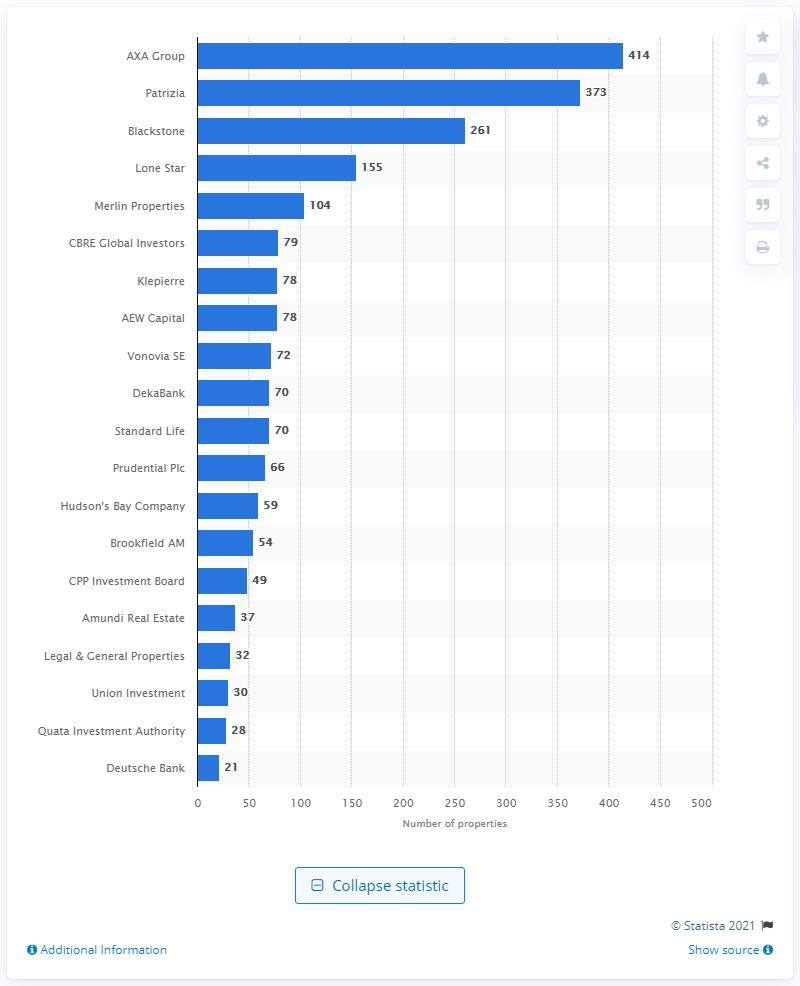Mention a couple of crucial points in this snapshot. In January 2016, the AXA Group purchased a total of 414 properties. In the 12 months leading up to January 2016, Blackstone Group acquired a total of 261 properties. Patrizia Immobilien AG purchased 373 properties in the 12 months leading up to January 2016. 